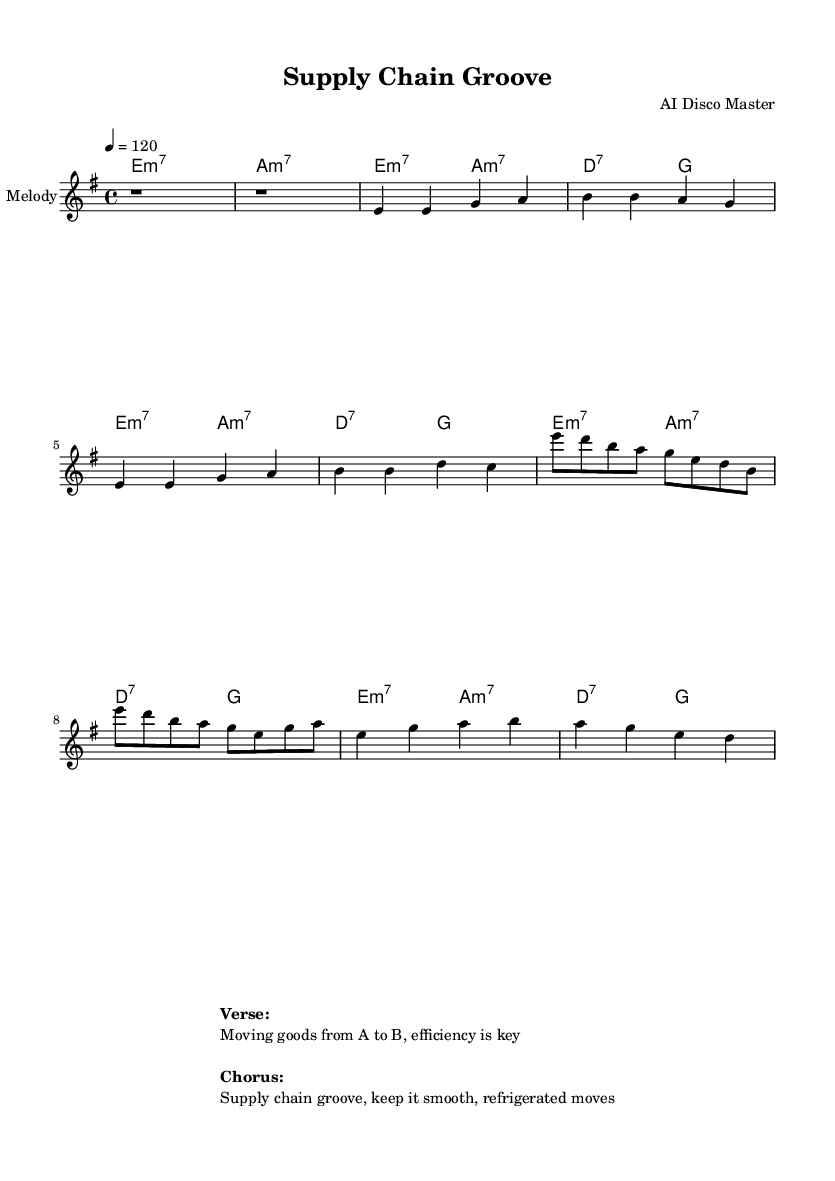What is the key signature of this music? The key signature is E minor, which contains one sharp (F#). This can be determined by looking at the key signature indication at the beginning of the music.
Answer: E minor What is the time signature of this music? The time signature is 4/4, indicating four beats per measure. This is labeled at the beginning of the piece and is a common time signature in dance music.
Answer: 4/4 What is the tempo marking of this piece? The tempo marking indicates a tempo of 120 beats per minute. This is shown in the score as "4 = 120," which means that the quarter note gets the beat at this speed.
Answer: 120 How many measures are in the verse section? The verse section contains four measures, which can be counted by looking at the notation in the melody part. Each complete grouping of notes separated by vertical lines represents a measure.
Answer: 4 What chord follows the first melody note in the chorus? The first melody note in the chorus is E, and the chord that accompanies it is E minor 7. This can be determined by looking at the chord changes indicated above the melody in the score.
Answer: E minor 7 What is the main theme of the lyrics in the chorus? The main theme of the lyrics in the chorus is about keeping supply chains smooth and efficient. This is derived from the textual annotation provided below the score.
Answer: Supply chain groove, keep it smooth How does the bridge connect back to the verse? The bridge uses the same chords (E minor 7 and A minor 7) as the verse, creating a cohesive sound that returns to the familiar harmonic structure. This can be seen by comparing the chord sequences from both sections.
Answer: Same chords 